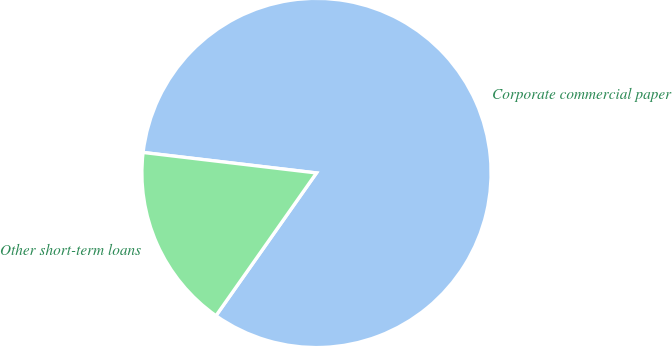<chart> <loc_0><loc_0><loc_500><loc_500><pie_chart><fcel>Corporate commercial paper<fcel>Other short-term loans<nl><fcel>82.89%<fcel>17.11%<nl></chart> 